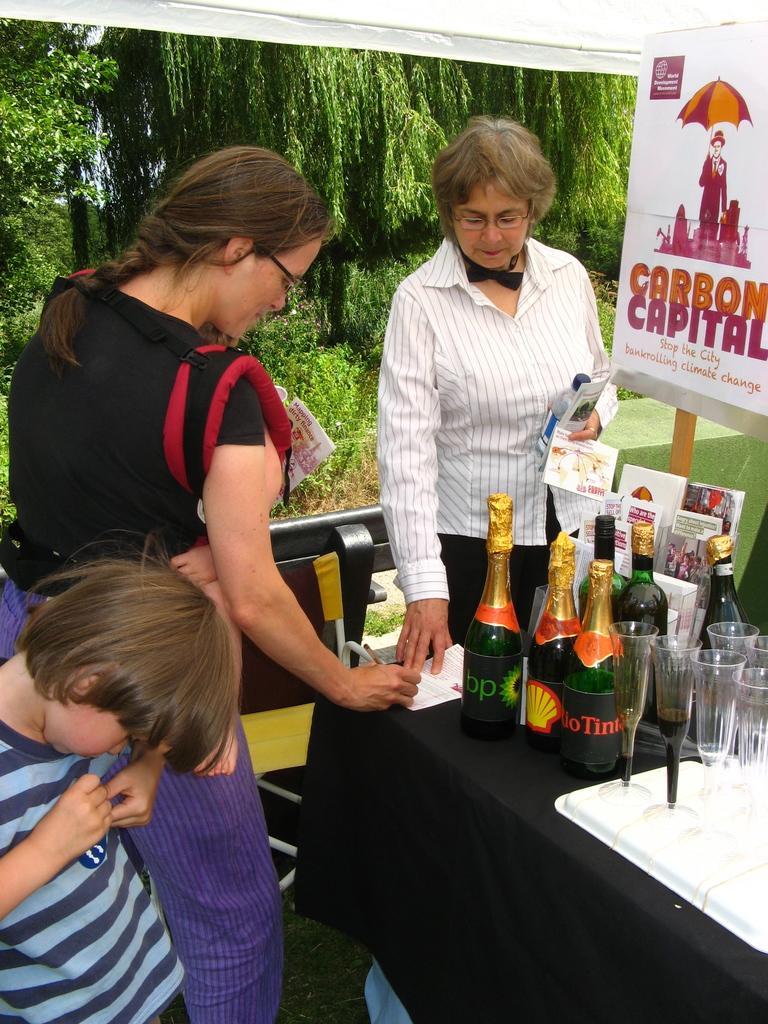Could you give a brief overview of what you see in this image? In this picture we can see two women's the first one writing something on the paper and the second one looking at that paper, you can see a table on the table you can see wine bottles and glasses and some books too. There is a boy in the bottom left corner you can see trees chairs and grass. 